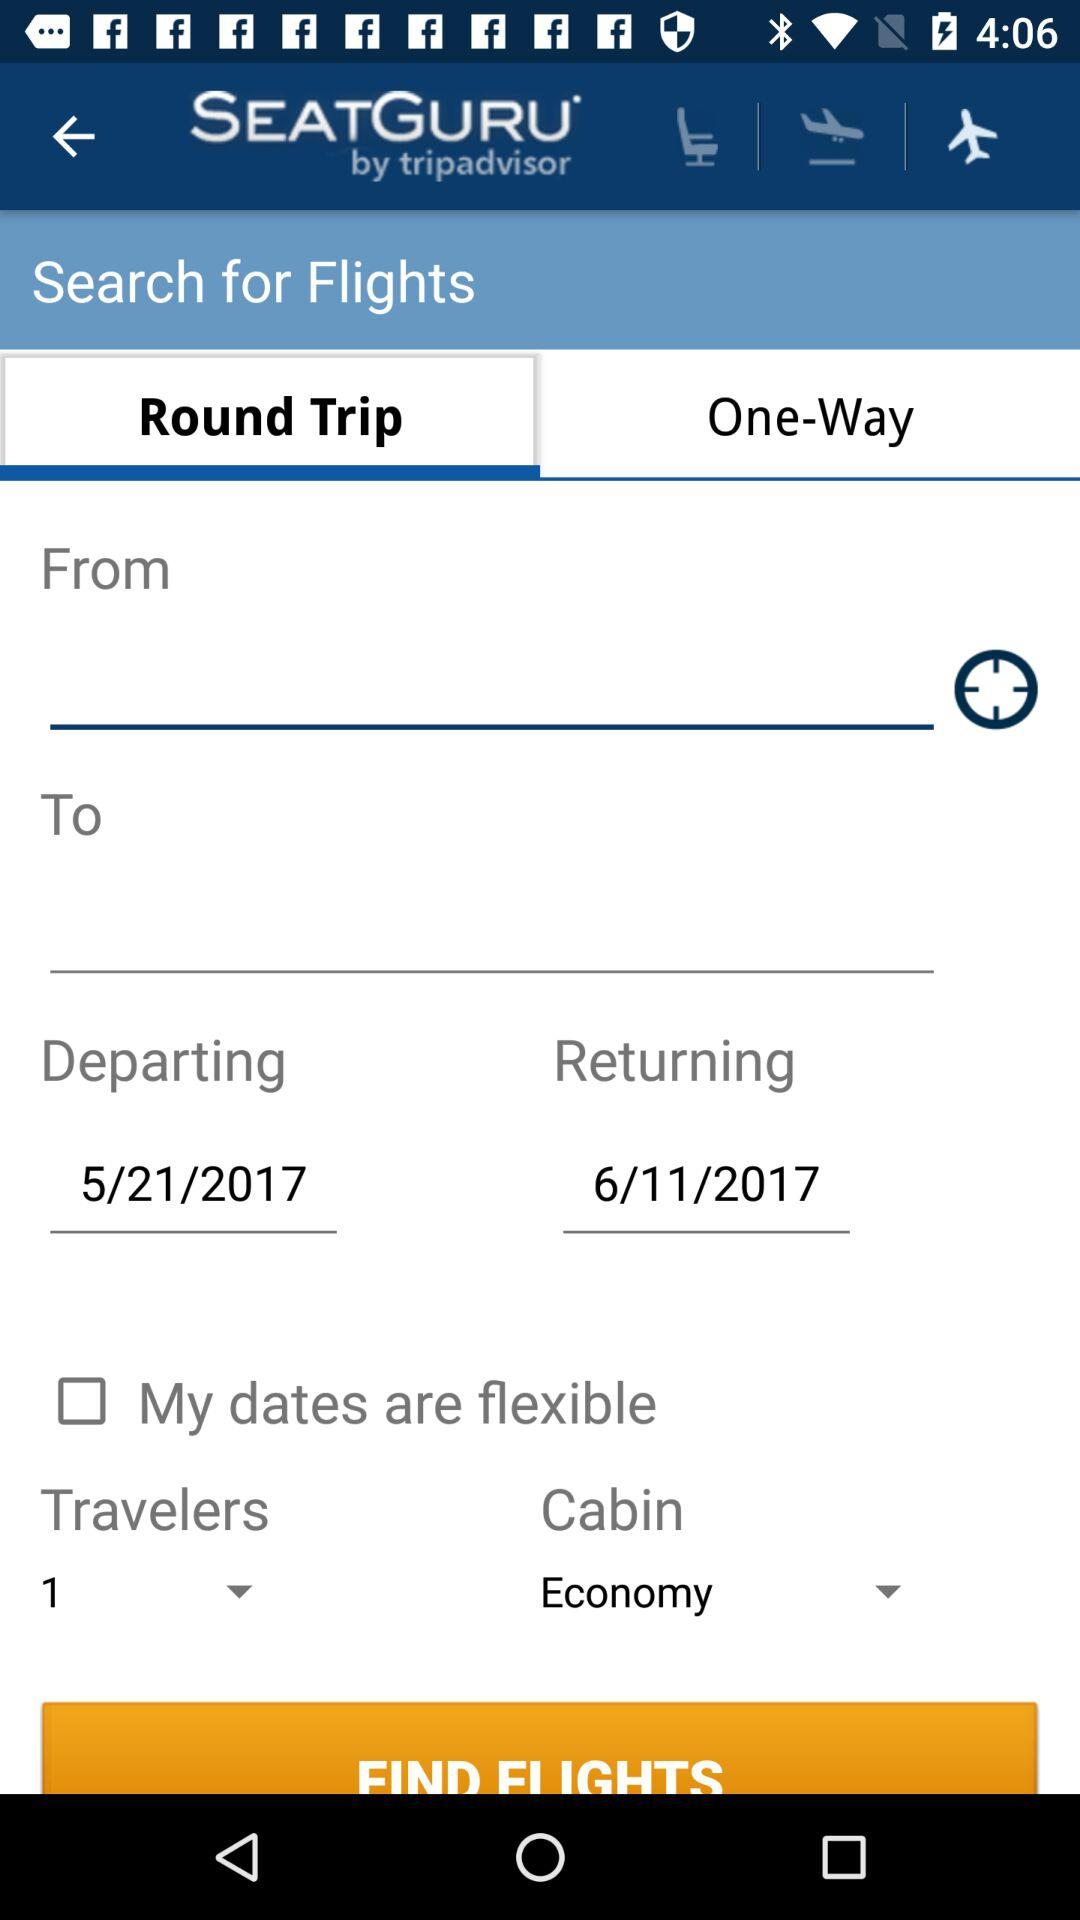How many people are traveling?
Answer the question using a single word or phrase. 1 